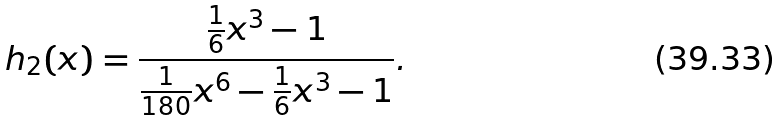<formula> <loc_0><loc_0><loc_500><loc_500>h _ { 2 } ( x ) = \frac { \frac { 1 } { 6 } x ^ { 3 } - 1 } { \frac { 1 } { 1 8 0 } x ^ { 6 } - \frac { 1 } { 6 } x ^ { 3 } - 1 } .</formula> 